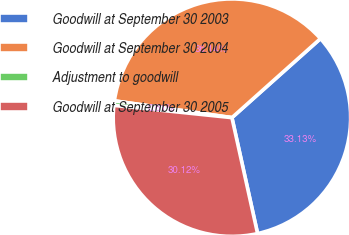<chart> <loc_0><loc_0><loc_500><loc_500><pie_chart><fcel>Goodwill at September 30 2003<fcel>Goodwill at September 30 2004<fcel>Adjustment to goodwill<fcel>Goodwill at September 30 2005<nl><fcel>33.13%<fcel>36.14%<fcel>0.61%<fcel>30.12%<nl></chart> 